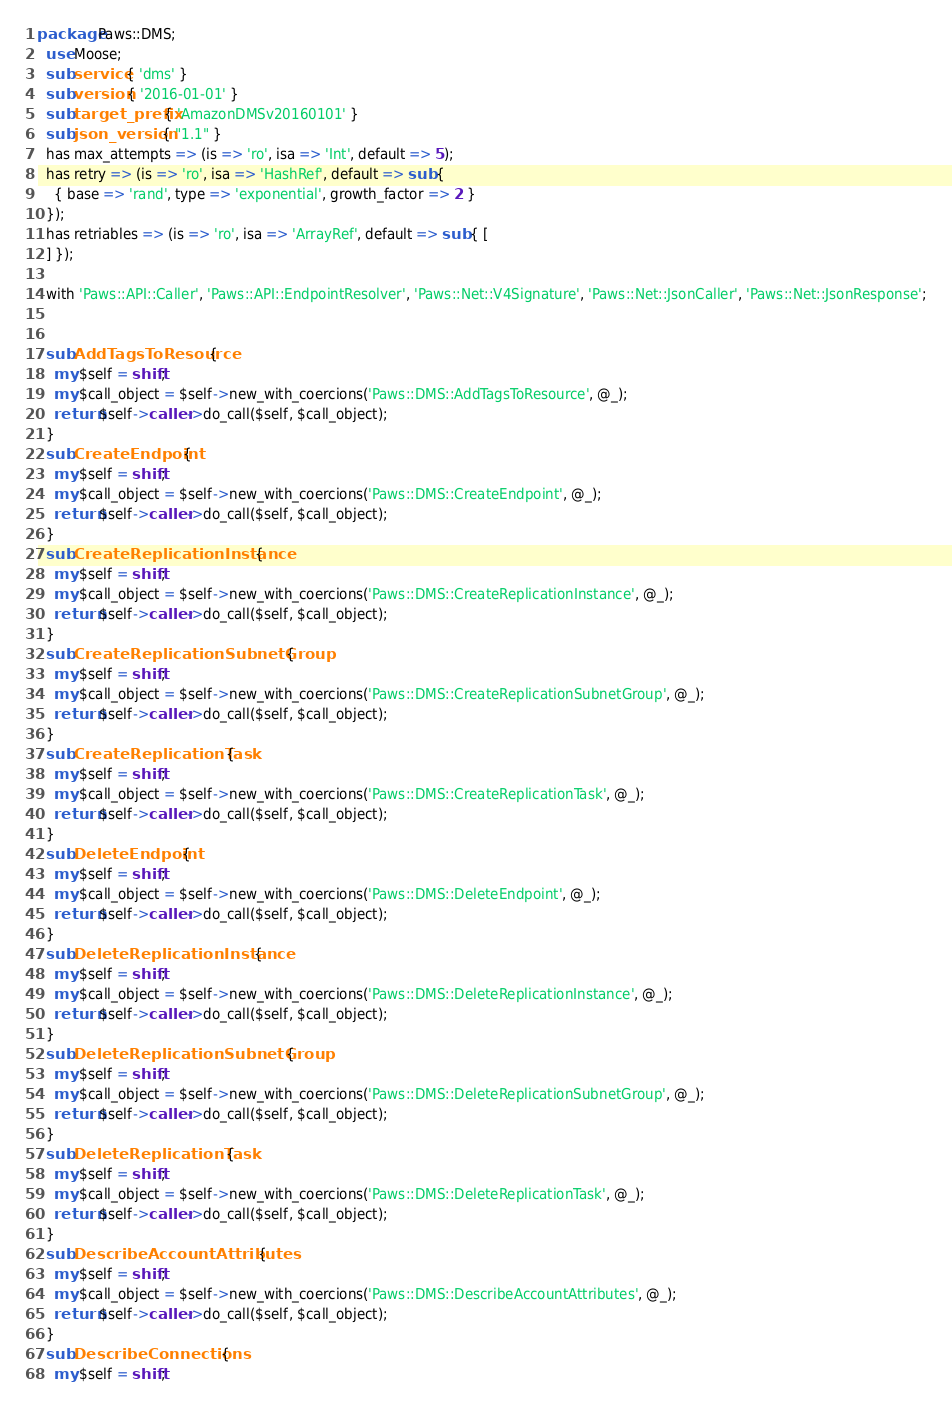<code> <loc_0><loc_0><loc_500><loc_500><_Perl_>package Paws::DMS;
  use Moose;
  sub service { 'dms' }
  sub version { '2016-01-01' }
  sub target_prefix { 'AmazonDMSv20160101' }
  sub json_version { "1.1" }
  has max_attempts => (is => 'ro', isa => 'Int', default => 5);
  has retry => (is => 'ro', isa => 'HashRef', default => sub {
    { base => 'rand', type => 'exponential', growth_factor => 2 }
  });
  has retriables => (is => 'ro', isa => 'ArrayRef', default => sub { [
  ] });

  with 'Paws::API::Caller', 'Paws::API::EndpointResolver', 'Paws::Net::V4Signature', 'Paws::Net::JsonCaller', 'Paws::Net::JsonResponse';

  
  sub AddTagsToResource {
    my $self = shift;
    my $call_object = $self->new_with_coercions('Paws::DMS::AddTagsToResource', @_);
    return $self->caller->do_call($self, $call_object);
  }
  sub CreateEndpoint {
    my $self = shift;
    my $call_object = $self->new_with_coercions('Paws::DMS::CreateEndpoint', @_);
    return $self->caller->do_call($self, $call_object);
  }
  sub CreateReplicationInstance {
    my $self = shift;
    my $call_object = $self->new_with_coercions('Paws::DMS::CreateReplicationInstance', @_);
    return $self->caller->do_call($self, $call_object);
  }
  sub CreateReplicationSubnetGroup {
    my $self = shift;
    my $call_object = $self->new_with_coercions('Paws::DMS::CreateReplicationSubnetGroup', @_);
    return $self->caller->do_call($self, $call_object);
  }
  sub CreateReplicationTask {
    my $self = shift;
    my $call_object = $self->new_with_coercions('Paws::DMS::CreateReplicationTask', @_);
    return $self->caller->do_call($self, $call_object);
  }
  sub DeleteEndpoint {
    my $self = shift;
    my $call_object = $self->new_with_coercions('Paws::DMS::DeleteEndpoint', @_);
    return $self->caller->do_call($self, $call_object);
  }
  sub DeleteReplicationInstance {
    my $self = shift;
    my $call_object = $self->new_with_coercions('Paws::DMS::DeleteReplicationInstance', @_);
    return $self->caller->do_call($self, $call_object);
  }
  sub DeleteReplicationSubnetGroup {
    my $self = shift;
    my $call_object = $self->new_with_coercions('Paws::DMS::DeleteReplicationSubnetGroup', @_);
    return $self->caller->do_call($self, $call_object);
  }
  sub DeleteReplicationTask {
    my $self = shift;
    my $call_object = $self->new_with_coercions('Paws::DMS::DeleteReplicationTask', @_);
    return $self->caller->do_call($self, $call_object);
  }
  sub DescribeAccountAttributes {
    my $self = shift;
    my $call_object = $self->new_with_coercions('Paws::DMS::DescribeAccountAttributes', @_);
    return $self->caller->do_call($self, $call_object);
  }
  sub DescribeConnections {
    my $self = shift;</code> 